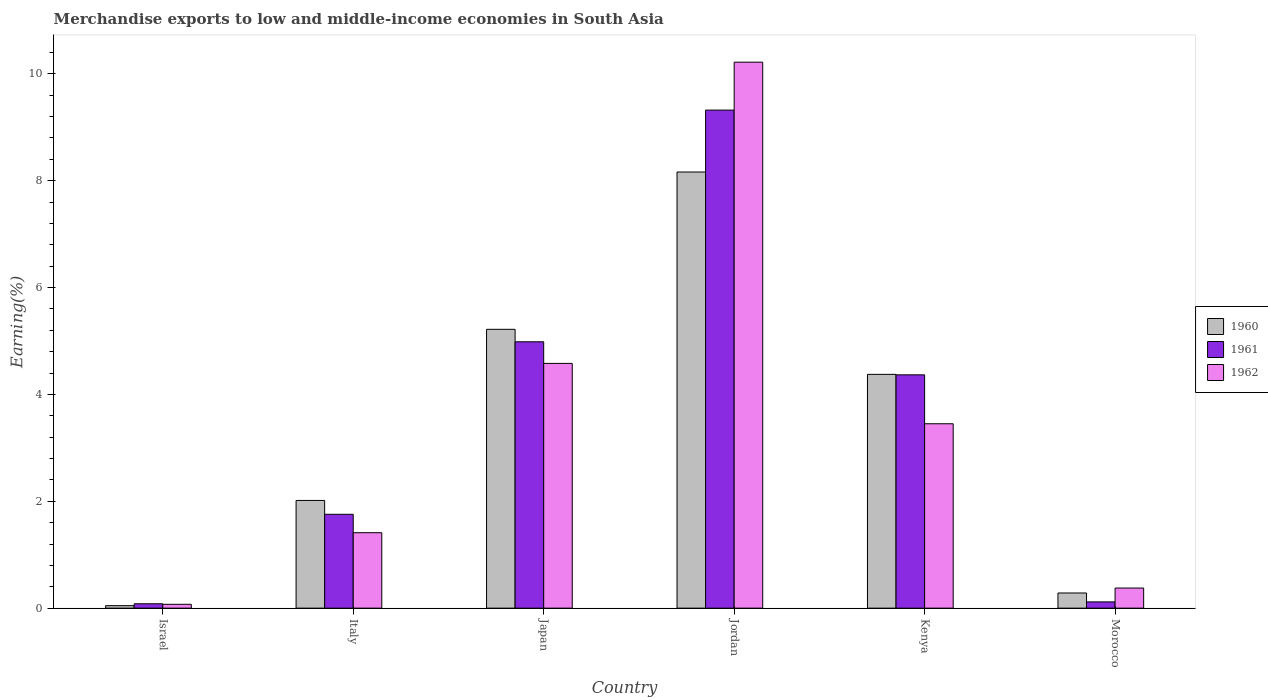How many different coloured bars are there?
Give a very brief answer. 3. Are the number of bars per tick equal to the number of legend labels?
Offer a terse response. Yes. Are the number of bars on each tick of the X-axis equal?
Your answer should be compact. Yes. In how many cases, is the number of bars for a given country not equal to the number of legend labels?
Ensure brevity in your answer.  0. What is the percentage of amount earned from merchandise exports in 1960 in Jordan?
Make the answer very short. 8.16. Across all countries, what is the maximum percentage of amount earned from merchandise exports in 1960?
Offer a terse response. 8.16. Across all countries, what is the minimum percentage of amount earned from merchandise exports in 1962?
Make the answer very short. 0.07. In which country was the percentage of amount earned from merchandise exports in 1962 maximum?
Your answer should be very brief. Jordan. What is the total percentage of amount earned from merchandise exports in 1960 in the graph?
Your answer should be compact. 20.1. What is the difference between the percentage of amount earned from merchandise exports in 1960 in Israel and that in Morocco?
Your response must be concise. -0.24. What is the difference between the percentage of amount earned from merchandise exports in 1962 in Italy and the percentage of amount earned from merchandise exports in 1961 in Japan?
Your answer should be very brief. -3.57. What is the average percentage of amount earned from merchandise exports in 1962 per country?
Offer a very short reply. 3.35. What is the difference between the percentage of amount earned from merchandise exports of/in 1961 and percentage of amount earned from merchandise exports of/in 1960 in Israel?
Make the answer very short. 0.04. What is the ratio of the percentage of amount earned from merchandise exports in 1961 in Israel to that in Kenya?
Make the answer very short. 0.02. What is the difference between the highest and the second highest percentage of amount earned from merchandise exports in 1960?
Offer a terse response. 3.79. What is the difference between the highest and the lowest percentage of amount earned from merchandise exports in 1961?
Ensure brevity in your answer.  9.24. Is the sum of the percentage of amount earned from merchandise exports in 1962 in Jordan and Morocco greater than the maximum percentage of amount earned from merchandise exports in 1961 across all countries?
Ensure brevity in your answer.  Yes. What does the 2nd bar from the right in Jordan represents?
Your response must be concise. 1961. Is it the case that in every country, the sum of the percentage of amount earned from merchandise exports in 1961 and percentage of amount earned from merchandise exports in 1962 is greater than the percentage of amount earned from merchandise exports in 1960?
Provide a short and direct response. Yes. How many bars are there?
Your answer should be compact. 18. How many countries are there in the graph?
Your response must be concise. 6. How many legend labels are there?
Make the answer very short. 3. What is the title of the graph?
Ensure brevity in your answer.  Merchandise exports to low and middle-income economies in South Asia. What is the label or title of the X-axis?
Make the answer very short. Country. What is the label or title of the Y-axis?
Give a very brief answer. Earning(%). What is the Earning(%) in 1960 in Israel?
Provide a short and direct response. 0.05. What is the Earning(%) in 1961 in Israel?
Make the answer very short. 0.08. What is the Earning(%) in 1962 in Israel?
Your response must be concise. 0.07. What is the Earning(%) in 1960 in Italy?
Provide a short and direct response. 2.02. What is the Earning(%) in 1961 in Italy?
Your answer should be compact. 1.76. What is the Earning(%) in 1962 in Italy?
Your answer should be compact. 1.41. What is the Earning(%) in 1960 in Japan?
Your answer should be compact. 5.22. What is the Earning(%) in 1961 in Japan?
Ensure brevity in your answer.  4.99. What is the Earning(%) of 1962 in Japan?
Provide a short and direct response. 4.58. What is the Earning(%) of 1960 in Jordan?
Provide a succinct answer. 8.16. What is the Earning(%) of 1961 in Jordan?
Provide a short and direct response. 9.32. What is the Earning(%) of 1962 in Jordan?
Your answer should be very brief. 10.22. What is the Earning(%) of 1960 in Kenya?
Your answer should be compact. 4.38. What is the Earning(%) in 1961 in Kenya?
Offer a very short reply. 4.37. What is the Earning(%) in 1962 in Kenya?
Your response must be concise. 3.45. What is the Earning(%) of 1960 in Morocco?
Your answer should be compact. 0.28. What is the Earning(%) of 1961 in Morocco?
Ensure brevity in your answer.  0.12. What is the Earning(%) in 1962 in Morocco?
Provide a succinct answer. 0.38. Across all countries, what is the maximum Earning(%) of 1960?
Offer a terse response. 8.16. Across all countries, what is the maximum Earning(%) of 1961?
Provide a succinct answer. 9.32. Across all countries, what is the maximum Earning(%) of 1962?
Your answer should be compact. 10.22. Across all countries, what is the minimum Earning(%) in 1960?
Provide a short and direct response. 0.05. Across all countries, what is the minimum Earning(%) of 1961?
Your response must be concise. 0.08. Across all countries, what is the minimum Earning(%) in 1962?
Make the answer very short. 0.07. What is the total Earning(%) in 1960 in the graph?
Your answer should be compact. 20.1. What is the total Earning(%) of 1961 in the graph?
Give a very brief answer. 20.63. What is the total Earning(%) of 1962 in the graph?
Your answer should be very brief. 20.11. What is the difference between the Earning(%) of 1960 in Israel and that in Italy?
Your answer should be very brief. -1.97. What is the difference between the Earning(%) of 1961 in Israel and that in Italy?
Your response must be concise. -1.68. What is the difference between the Earning(%) of 1962 in Israel and that in Italy?
Offer a very short reply. -1.34. What is the difference between the Earning(%) in 1960 in Israel and that in Japan?
Offer a very short reply. -5.17. What is the difference between the Earning(%) of 1961 in Israel and that in Japan?
Give a very brief answer. -4.9. What is the difference between the Earning(%) in 1962 in Israel and that in Japan?
Your answer should be compact. -4.51. What is the difference between the Earning(%) in 1960 in Israel and that in Jordan?
Keep it short and to the point. -8.12. What is the difference between the Earning(%) in 1961 in Israel and that in Jordan?
Offer a terse response. -9.24. What is the difference between the Earning(%) in 1962 in Israel and that in Jordan?
Keep it short and to the point. -10.15. What is the difference between the Earning(%) in 1960 in Israel and that in Kenya?
Offer a terse response. -4.33. What is the difference between the Earning(%) in 1961 in Israel and that in Kenya?
Ensure brevity in your answer.  -4.29. What is the difference between the Earning(%) of 1962 in Israel and that in Kenya?
Provide a succinct answer. -3.38. What is the difference between the Earning(%) in 1960 in Israel and that in Morocco?
Your answer should be very brief. -0.24. What is the difference between the Earning(%) in 1961 in Israel and that in Morocco?
Offer a very short reply. -0.04. What is the difference between the Earning(%) in 1962 in Israel and that in Morocco?
Your answer should be compact. -0.3. What is the difference between the Earning(%) of 1960 in Italy and that in Japan?
Make the answer very short. -3.2. What is the difference between the Earning(%) in 1961 in Italy and that in Japan?
Your answer should be very brief. -3.23. What is the difference between the Earning(%) of 1962 in Italy and that in Japan?
Ensure brevity in your answer.  -3.17. What is the difference between the Earning(%) of 1960 in Italy and that in Jordan?
Your answer should be compact. -6.15. What is the difference between the Earning(%) of 1961 in Italy and that in Jordan?
Your answer should be very brief. -7.57. What is the difference between the Earning(%) in 1962 in Italy and that in Jordan?
Your response must be concise. -8.81. What is the difference between the Earning(%) in 1960 in Italy and that in Kenya?
Your answer should be very brief. -2.36. What is the difference between the Earning(%) of 1961 in Italy and that in Kenya?
Your answer should be very brief. -2.61. What is the difference between the Earning(%) in 1962 in Italy and that in Kenya?
Provide a short and direct response. -2.04. What is the difference between the Earning(%) of 1960 in Italy and that in Morocco?
Give a very brief answer. 1.73. What is the difference between the Earning(%) in 1961 in Italy and that in Morocco?
Your answer should be compact. 1.64. What is the difference between the Earning(%) of 1962 in Italy and that in Morocco?
Provide a succinct answer. 1.04. What is the difference between the Earning(%) of 1960 in Japan and that in Jordan?
Your response must be concise. -2.94. What is the difference between the Earning(%) of 1961 in Japan and that in Jordan?
Give a very brief answer. -4.34. What is the difference between the Earning(%) of 1962 in Japan and that in Jordan?
Make the answer very short. -5.64. What is the difference between the Earning(%) of 1960 in Japan and that in Kenya?
Your answer should be compact. 0.84. What is the difference between the Earning(%) in 1961 in Japan and that in Kenya?
Keep it short and to the point. 0.62. What is the difference between the Earning(%) of 1962 in Japan and that in Kenya?
Your response must be concise. 1.13. What is the difference between the Earning(%) in 1960 in Japan and that in Morocco?
Provide a succinct answer. 4.93. What is the difference between the Earning(%) in 1961 in Japan and that in Morocco?
Give a very brief answer. 4.87. What is the difference between the Earning(%) in 1962 in Japan and that in Morocco?
Provide a short and direct response. 4.2. What is the difference between the Earning(%) in 1960 in Jordan and that in Kenya?
Provide a short and direct response. 3.79. What is the difference between the Earning(%) in 1961 in Jordan and that in Kenya?
Offer a terse response. 4.96. What is the difference between the Earning(%) of 1962 in Jordan and that in Kenya?
Keep it short and to the point. 6.77. What is the difference between the Earning(%) of 1960 in Jordan and that in Morocco?
Your response must be concise. 7.88. What is the difference between the Earning(%) in 1961 in Jordan and that in Morocco?
Give a very brief answer. 9.21. What is the difference between the Earning(%) of 1962 in Jordan and that in Morocco?
Provide a short and direct response. 9.84. What is the difference between the Earning(%) of 1960 in Kenya and that in Morocco?
Provide a short and direct response. 4.09. What is the difference between the Earning(%) in 1961 in Kenya and that in Morocco?
Your answer should be compact. 4.25. What is the difference between the Earning(%) of 1962 in Kenya and that in Morocco?
Your answer should be very brief. 3.07. What is the difference between the Earning(%) of 1960 in Israel and the Earning(%) of 1961 in Italy?
Offer a terse response. -1.71. What is the difference between the Earning(%) in 1960 in Israel and the Earning(%) in 1962 in Italy?
Your answer should be very brief. -1.37. What is the difference between the Earning(%) in 1961 in Israel and the Earning(%) in 1962 in Italy?
Your answer should be compact. -1.33. What is the difference between the Earning(%) in 1960 in Israel and the Earning(%) in 1961 in Japan?
Give a very brief answer. -4.94. What is the difference between the Earning(%) of 1960 in Israel and the Earning(%) of 1962 in Japan?
Ensure brevity in your answer.  -4.53. What is the difference between the Earning(%) in 1961 in Israel and the Earning(%) in 1962 in Japan?
Offer a very short reply. -4.5. What is the difference between the Earning(%) of 1960 in Israel and the Earning(%) of 1961 in Jordan?
Your response must be concise. -9.28. What is the difference between the Earning(%) in 1960 in Israel and the Earning(%) in 1962 in Jordan?
Give a very brief answer. -10.17. What is the difference between the Earning(%) in 1961 in Israel and the Earning(%) in 1962 in Jordan?
Offer a very short reply. -10.14. What is the difference between the Earning(%) in 1960 in Israel and the Earning(%) in 1961 in Kenya?
Give a very brief answer. -4.32. What is the difference between the Earning(%) of 1960 in Israel and the Earning(%) of 1962 in Kenya?
Provide a succinct answer. -3.4. What is the difference between the Earning(%) in 1961 in Israel and the Earning(%) in 1962 in Kenya?
Provide a short and direct response. -3.37. What is the difference between the Earning(%) in 1960 in Israel and the Earning(%) in 1961 in Morocco?
Offer a terse response. -0.07. What is the difference between the Earning(%) in 1960 in Israel and the Earning(%) in 1962 in Morocco?
Offer a very short reply. -0.33. What is the difference between the Earning(%) of 1961 in Israel and the Earning(%) of 1962 in Morocco?
Keep it short and to the point. -0.29. What is the difference between the Earning(%) of 1960 in Italy and the Earning(%) of 1961 in Japan?
Ensure brevity in your answer.  -2.97. What is the difference between the Earning(%) in 1960 in Italy and the Earning(%) in 1962 in Japan?
Offer a terse response. -2.56. What is the difference between the Earning(%) of 1961 in Italy and the Earning(%) of 1962 in Japan?
Keep it short and to the point. -2.82. What is the difference between the Earning(%) in 1960 in Italy and the Earning(%) in 1961 in Jordan?
Provide a succinct answer. -7.31. What is the difference between the Earning(%) in 1960 in Italy and the Earning(%) in 1962 in Jordan?
Your response must be concise. -8.2. What is the difference between the Earning(%) in 1961 in Italy and the Earning(%) in 1962 in Jordan?
Give a very brief answer. -8.46. What is the difference between the Earning(%) in 1960 in Italy and the Earning(%) in 1961 in Kenya?
Your response must be concise. -2.35. What is the difference between the Earning(%) of 1960 in Italy and the Earning(%) of 1962 in Kenya?
Give a very brief answer. -1.44. What is the difference between the Earning(%) of 1961 in Italy and the Earning(%) of 1962 in Kenya?
Make the answer very short. -1.69. What is the difference between the Earning(%) of 1960 in Italy and the Earning(%) of 1961 in Morocco?
Provide a short and direct response. 1.9. What is the difference between the Earning(%) in 1960 in Italy and the Earning(%) in 1962 in Morocco?
Your answer should be compact. 1.64. What is the difference between the Earning(%) of 1961 in Italy and the Earning(%) of 1962 in Morocco?
Keep it short and to the point. 1.38. What is the difference between the Earning(%) in 1960 in Japan and the Earning(%) in 1961 in Jordan?
Offer a terse response. -4.1. What is the difference between the Earning(%) of 1960 in Japan and the Earning(%) of 1962 in Jordan?
Provide a succinct answer. -5. What is the difference between the Earning(%) in 1961 in Japan and the Earning(%) in 1962 in Jordan?
Your answer should be compact. -5.23. What is the difference between the Earning(%) in 1960 in Japan and the Earning(%) in 1961 in Kenya?
Your answer should be compact. 0.85. What is the difference between the Earning(%) in 1960 in Japan and the Earning(%) in 1962 in Kenya?
Make the answer very short. 1.77. What is the difference between the Earning(%) of 1961 in Japan and the Earning(%) of 1962 in Kenya?
Give a very brief answer. 1.53. What is the difference between the Earning(%) in 1960 in Japan and the Earning(%) in 1961 in Morocco?
Make the answer very short. 5.1. What is the difference between the Earning(%) in 1960 in Japan and the Earning(%) in 1962 in Morocco?
Make the answer very short. 4.84. What is the difference between the Earning(%) in 1961 in Japan and the Earning(%) in 1962 in Morocco?
Your answer should be very brief. 4.61. What is the difference between the Earning(%) of 1960 in Jordan and the Earning(%) of 1961 in Kenya?
Your answer should be very brief. 3.8. What is the difference between the Earning(%) of 1960 in Jordan and the Earning(%) of 1962 in Kenya?
Offer a terse response. 4.71. What is the difference between the Earning(%) of 1961 in Jordan and the Earning(%) of 1962 in Kenya?
Keep it short and to the point. 5.87. What is the difference between the Earning(%) of 1960 in Jordan and the Earning(%) of 1961 in Morocco?
Your answer should be very brief. 8.05. What is the difference between the Earning(%) of 1960 in Jordan and the Earning(%) of 1962 in Morocco?
Provide a succinct answer. 7.79. What is the difference between the Earning(%) in 1961 in Jordan and the Earning(%) in 1962 in Morocco?
Make the answer very short. 8.95. What is the difference between the Earning(%) of 1960 in Kenya and the Earning(%) of 1961 in Morocco?
Provide a short and direct response. 4.26. What is the difference between the Earning(%) of 1960 in Kenya and the Earning(%) of 1962 in Morocco?
Keep it short and to the point. 4. What is the difference between the Earning(%) of 1961 in Kenya and the Earning(%) of 1962 in Morocco?
Offer a very short reply. 3.99. What is the average Earning(%) in 1960 per country?
Give a very brief answer. 3.35. What is the average Earning(%) of 1961 per country?
Ensure brevity in your answer.  3.44. What is the average Earning(%) in 1962 per country?
Give a very brief answer. 3.35. What is the difference between the Earning(%) of 1960 and Earning(%) of 1961 in Israel?
Provide a short and direct response. -0.04. What is the difference between the Earning(%) in 1960 and Earning(%) in 1962 in Israel?
Your answer should be compact. -0.03. What is the difference between the Earning(%) of 1961 and Earning(%) of 1962 in Israel?
Ensure brevity in your answer.  0.01. What is the difference between the Earning(%) of 1960 and Earning(%) of 1961 in Italy?
Your response must be concise. 0.26. What is the difference between the Earning(%) in 1960 and Earning(%) in 1962 in Italy?
Give a very brief answer. 0.6. What is the difference between the Earning(%) in 1961 and Earning(%) in 1962 in Italy?
Your answer should be very brief. 0.34. What is the difference between the Earning(%) in 1960 and Earning(%) in 1961 in Japan?
Keep it short and to the point. 0.23. What is the difference between the Earning(%) of 1960 and Earning(%) of 1962 in Japan?
Offer a terse response. 0.64. What is the difference between the Earning(%) of 1961 and Earning(%) of 1962 in Japan?
Keep it short and to the point. 0.4. What is the difference between the Earning(%) of 1960 and Earning(%) of 1961 in Jordan?
Your answer should be very brief. -1.16. What is the difference between the Earning(%) of 1960 and Earning(%) of 1962 in Jordan?
Keep it short and to the point. -2.06. What is the difference between the Earning(%) of 1961 and Earning(%) of 1962 in Jordan?
Provide a succinct answer. -0.9. What is the difference between the Earning(%) of 1960 and Earning(%) of 1961 in Kenya?
Make the answer very short. 0.01. What is the difference between the Earning(%) of 1960 and Earning(%) of 1962 in Kenya?
Keep it short and to the point. 0.92. What is the difference between the Earning(%) in 1961 and Earning(%) in 1962 in Kenya?
Your answer should be compact. 0.92. What is the difference between the Earning(%) of 1960 and Earning(%) of 1961 in Morocco?
Keep it short and to the point. 0.17. What is the difference between the Earning(%) of 1960 and Earning(%) of 1962 in Morocco?
Ensure brevity in your answer.  -0.09. What is the difference between the Earning(%) in 1961 and Earning(%) in 1962 in Morocco?
Provide a short and direct response. -0.26. What is the ratio of the Earning(%) in 1960 in Israel to that in Italy?
Offer a very short reply. 0.02. What is the ratio of the Earning(%) of 1961 in Israel to that in Italy?
Offer a terse response. 0.05. What is the ratio of the Earning(%) of 1962 in Israel to that in Italy?
Give a very brief answer. 0.05. What is the ratio of the Earning(%) in 1960 in Israel to that in Japan?
Ensure brevity in your answer.  0.01. What is the ratio of the Earning(%) in 1961 in Israel to that in Japan?
Give a very brief answer. 0.02. What is the ratio of the Earning(%) of 1962 in Israel to that in Japan?
Keep it short and to the point. 0.02. What is the ratio of the Earning(%) in 1960 in Israel to that in Jordan?
Ensure brevity in your answer.  0.01. What is the ratio of the Earning(%) in 1961 in Israel to that in Jordan?
Give a very brief answer. 0.01. What is the ratio of the Earning(%) of 1962 in Israel to that in Jordan?
Ensure brevity in your answer.  0.01. What is the ratio of the Earning(%) of 1960 in Israel to that in Kenya?
Provide a succinct answer. 0.01. What is the ratio of the Earning(%) in 1961 in Israel to that in Kenya?
Make the answer very short. 0.02. What is the ratio of the Earning(%) of 1962 in Israel to that in Kenya?
Your answer should be very brief. 0.02. What is the ratio of the Earning(%) in 1960 in Israel to that in Morocco?
Your answer should be compact. 0.16. What is the ratio of the Earning(%) in 1961 in Israel to that in Morocco?
Your answer should be compact. 0.7. What is the ratio of the Earning(%) in 1962 in Israel to that in Morocco?
Provide a short and direct response. 0.19. What is the ratio of the Earning(%) in 1960 in Italy to that in Japan?
Provide a succinct answer. 0.39. What is the ratio of the Earning(%) of 1961 in Italy to that in Japan?
Give a very brief answer. 0.35. What is the ratio of the Earning(%) in 1962 in Italy to that in Japan?
Offer a very short reply. 0.31. What is the ratio of the Earning(%) of 1960 in Italy to that in Jordan?
Offer a very short reply. 0.25. What is the ratio of the Earning(%) in 1961 in Italy to that in Jordan?
Offer a terse response. 0.19. What is the ratio of the Earning(%) in 1962 in Italy to that in Jordan?
Your answer should be very brief. 0.14. What is the ratio of the Earning(%) in 1960 in Italy to that in Kenya?
Make the answer very short. 0.46. What is the ratio of the Earning(%) in 1961 in Italy to that in Kenya?
Offer a terse response. 0.4. What is the ratio of the Earning(%) of 1962 in Italy to that in Kenya?
Your answer should be very brief. 0.41. What is the ratio of the Earning(%) of 1960 in Italy to that in Morocco?
Give a very brief answer. 7.1. What is the ratio of the Earning(%) in 1961 in Italy to that in Morocco?
Offer a terse response. 15.02. What is the ratio of the Earning(%) of 1962 in Italy to that in Morocco?
Offer a terse response. 3.75. What is the ratio of the Earning(%) in 1960 in Japan to that in Jordan?
Provide a succinct answer. 0.64. What is the ratio of the Earning(%) of 1961 in Japan to that in Jordan?
Your response must be concise. 0.53. What is the ratio of the Earning(%) of 1962 in Japan to that in Jordan?
Your answer should be compact. 0.45. What is the ratio of the Earning(%) of 1960 in Japan to that in Kenya?
Provide a succinct answer. 1.19. What is the ratio of the Earning(%) of 1961 in Japan to that in Kenya?
Make the answer very short. 1.14. What is the ratio of the Earning(%) in 1962 in Japan to that in Kenya?
Your answer should be very brief. 1.33. What is the ratio of the Earning(%) in 1960 in Japan to that in Morocco?
Make the answer very short. 18.39. What is the ratio of the Earning(%) in 1961 in Japan to that in Morocco?
Offer a terse response. 42.61. What is the ratio of the Earning(%) of 1962 in Japan to that in Morocco?
Give a very brief answer. 12.17. What is the ratio of the Earning(%) of 1960 in Jordan to that in Kenya?
Your answer should be compact. 1.87. What is the ratio of the Earning(%) of 1961 in Jordan to that in Kenya?
Provide a succinct answer. 2.13. What is the ratio of the Earning(%) of 1962 in Jordan to that in Kenya?
Provide a succinct answer. 2.96. What is the ratio of the Earning(%) of 1960 in Jordan to that in Morocco?
Your answer should be very brief. 28.77. What is the ratio of the Earning(%) of 1961 in Jordan to that in Morocco?
Your response must be concise. 79.68. What is the ratio of the Earning(%) of 1962 in Jordan to that in Morocco?
Your answer should be very brief. 27.14. What is the ratio of the Earning(%) in 1960 in Kenya to that in Morocco?
Ensure brevity in your answer.  15.42. What is the ratio of the Earning(%) in 1961 in Kenya to that in Morocco?
Ensure brevity in your answer.  37.33. What is the ratio of the Earning(%) of 1962 in Kenya to that in Morocco?
Keep it short and to the point. 9.17. What is the difference between the highest and the second highest Earning(%) in 1960?
Keep it short and to the point. 2.94. What is the difference between the highest and the second highest Earning(%) of 1961?
Your response must be concise. 4.34. What is the difference between the highest and the second highest Earning(%) in 1962?
Give a very brief answer. 5.64. What is the difference between the highest and the lowest Earning(%) in 1960?
Offer a very short reply. 8.12. What is the difference between the highest and the lowest Earning(%) of 1961?
Provide a succinct answer. 9.24. What is the difference between the highest and the lowest Earning(%) of 1962?
Offer a very short reply. 10.15. 